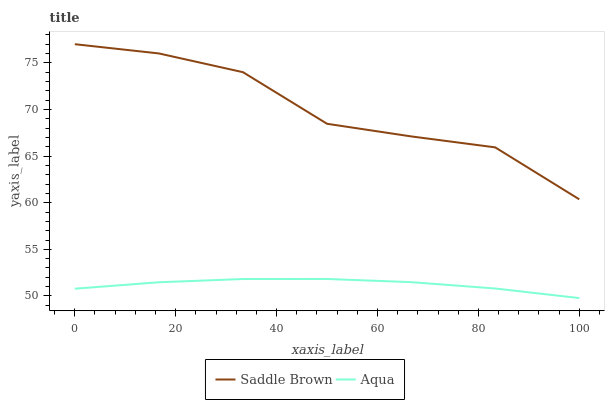Does Saddle Brown have the minimum area under the curve?
Answer yes or no. No. Is Saddle Brown the smoothest?
Answer yes or no. No. Does Saddle Brown have the lowest value?
Answer yes or no. No. Is Aqua less than Saddle Brown?
Answer yes or no. Yes. Is Saddle Brown greater than Aqua?
Answer yes or no. Yes. Does Aqua intersect Saddle Brown?
Answer yes or no. No. 